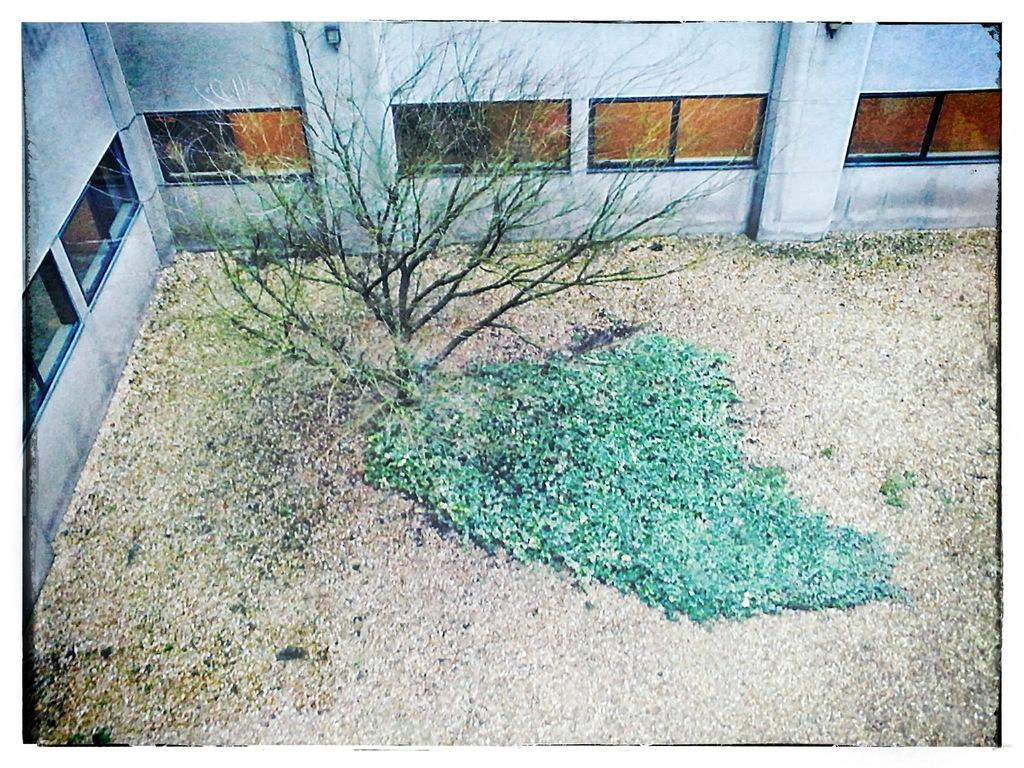What type of vegetation is present in the image? There is a tree in the image. What else can be seen on the ground besides the tree? There are plants on the ground. What architectural feature is visible in the image? There is a wall with pillars in the image. What can be seen on the wall? There are windows on the wall. What nation was discovered by the plants in the image? There is no mention of a nation or any discovery in the image; it features a tree, plants on the ground, a wall with pillars, and windows. 